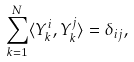<formula> <loc_0><loc_0><loc_500><loc_500>\sum _ { k = 1 } ^ { N } \langle Y _ { k } ^ { i } , Y _ { k } ^ { j } \rangle = \delta _ { i j } ,</formula> 